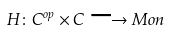Convert formula to latex. <formula><loc_0><loc_0><loc_500><loc_500>H \colon C ^ { o p } \times C \longrightarrow M o n</formula> 